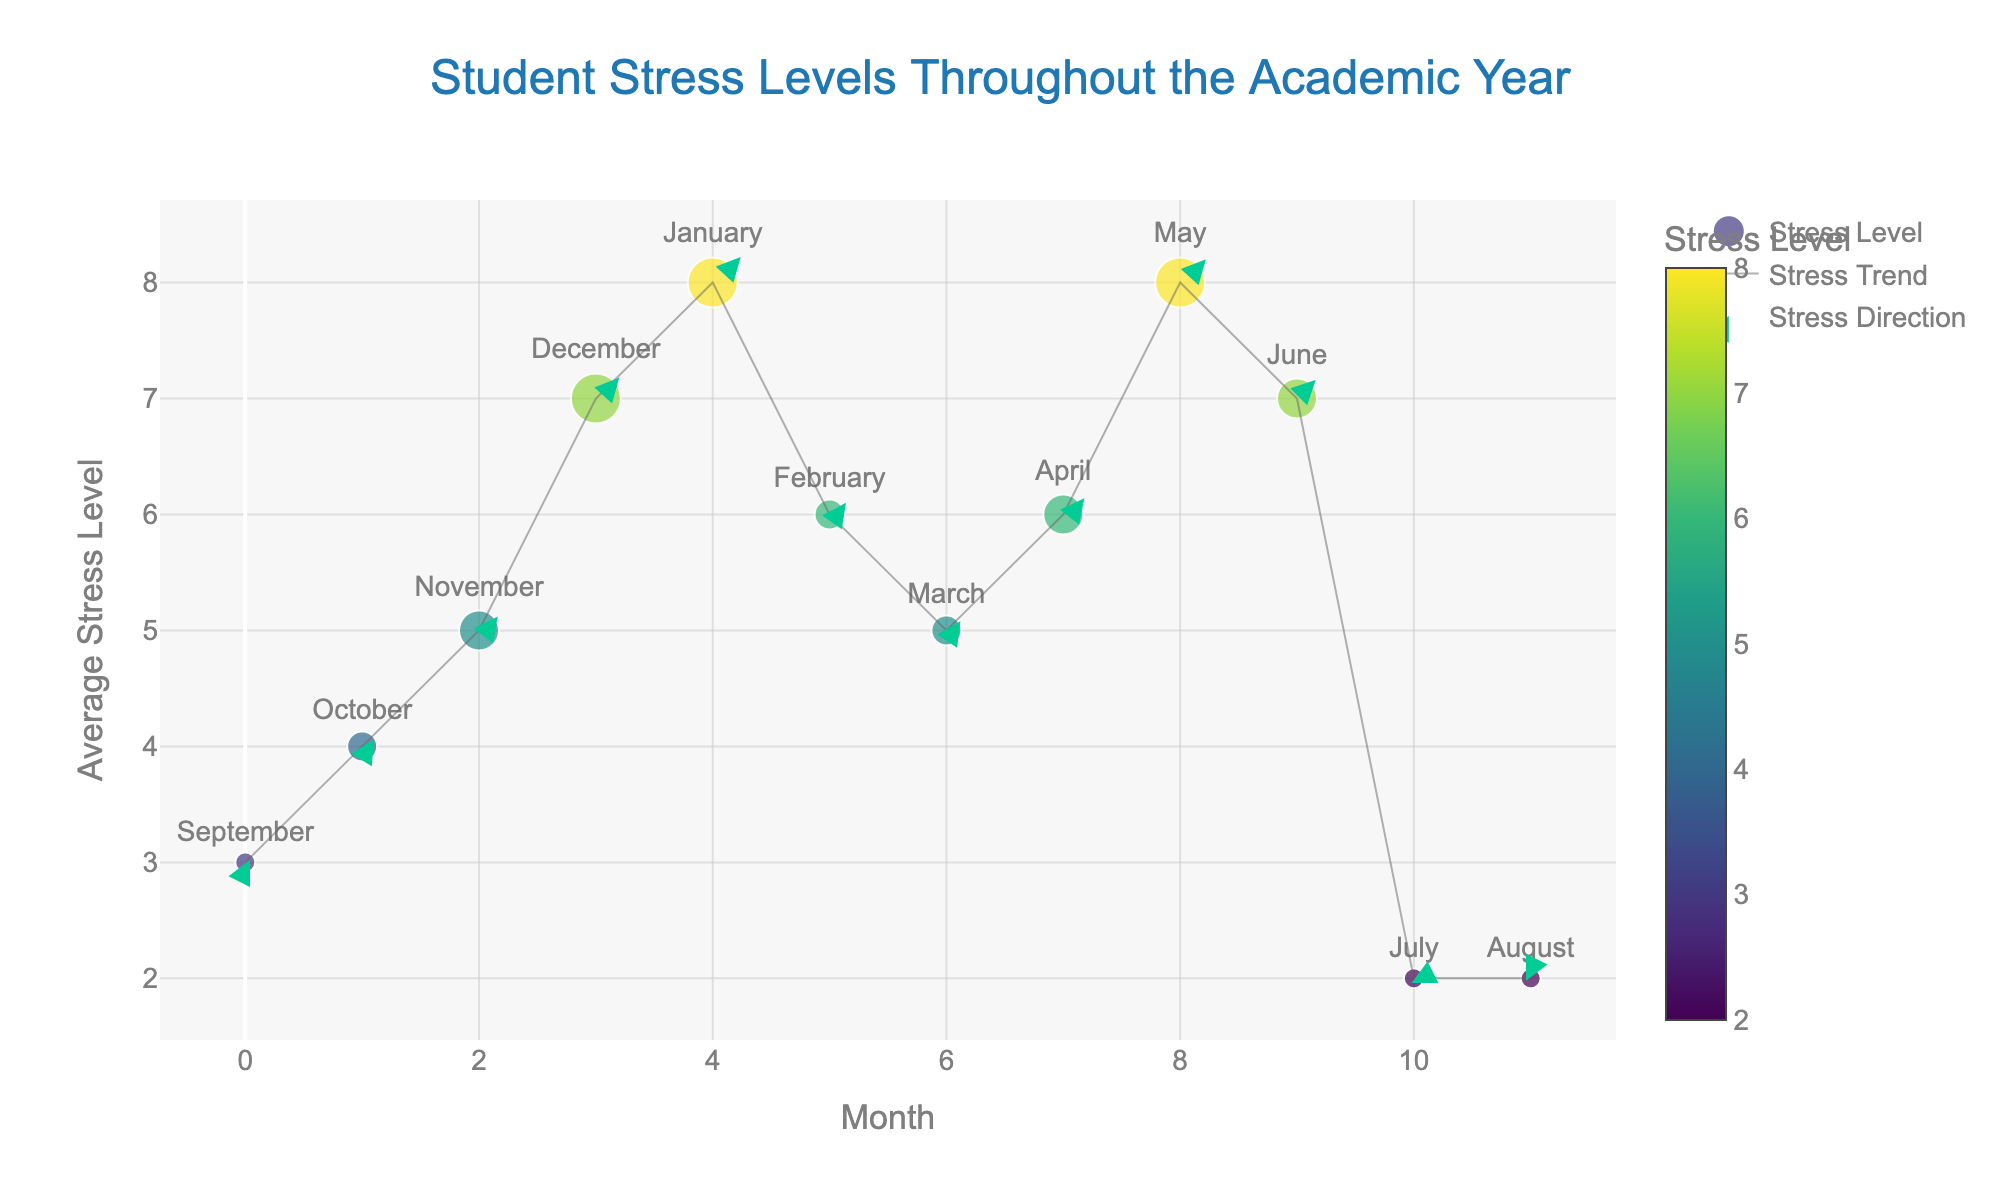What is the title of the quiver plot? The title of a plot is typically located at the top of the figure and is usually larger than the other text. Here, it reads 'Student Stress Levels Throughout the Academic Year.'
Answer: Student Stress Levels Throughout the Academic Year Which month has the highest average stress level? The average stress levels are plotted on the y-axis. The highest point on the y-axis corresponds to January and May, both having a stress level of 8.
Answer: January and May How does the stress level in February compare to that in March? Referring to the y-axis values for February and March, February has a stress level of 6, whereas March has a stress level of 5. Therefore, February's stress level is higher by 1.
Answer: February is higher What is the stress level trend from September to December? By following the line connecting the points from September to December, it is evident that the stress level increases from 3 in September to 7 in December, indicating an upward trend.
Answer: Upward trend During which months is the stress direction arrows pointing upward, indicating an increase in stress level? The arrows represent the direction and magnitude of stress changes. Upward arrows are observed when looking from September to January, and again from April to May, indicating stress increases in those periods.
Answer: September to January, April to May Which month has the smallest stress level change indicated by the direction arrows? Arrows with the smallest magnitude indicate the smallest stress level change. The arrows in July and August are the smallest, indicating the least change in stress levels.
Answer: July and August How does the stress level in November compare to that in February? Comparing the y-values for November and February, November has an average stress level of 5, while February has a stress level of 6. Thus, February is higher by 1 level.
Answer: February is higher What is the relationship between exam period intensity and average stress level? Observing the size of the markers, which represent exam period intensity, larger markers (higher exam intensity) correspond to higher average stress levels. For example, December and May have high stress levels and large markers, indicating higher exam intensity.
Answer: Higher exam intensity, higher stress level When does the stress level decrease throughout the year? Stress levels decrease when moving from higher to lower y-values. This happens from January to February and from June to July.
Answer: January to February, June to July What is the intensity of exam periods in March? The size of the markers indicate the exam intensity. The marker in March is of mid-size, corresponding to an exam period intensity of 1.
Answer: 1 